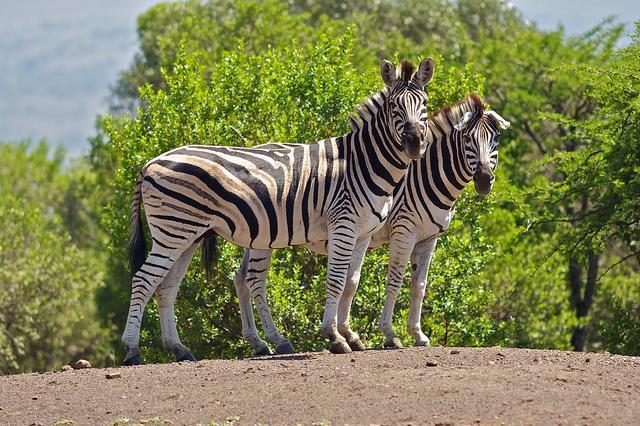How many zebras are in the picture?
Give a very brief answer. 2. How many zebras are there?
Give a very brief answer. 2. How many umbrellas are in the scene?
Give a very brief answer. 0. 